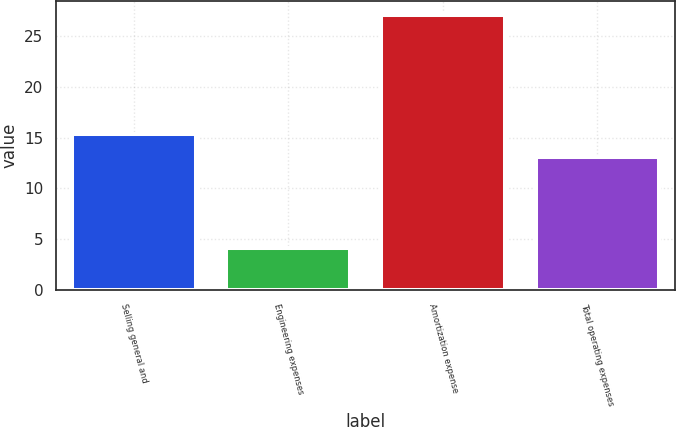Convert chart to OTSL. <chart><loc_0><loc_0><loc_500><loc_500><bar_chart><fcel>Selling general and<fcel>Engineering expenses<fcel>Amortization expense<fcel>Total operating expenses<nl><fcel>15.4<fcel>4.1<fcel>27.1<fcel>13.1<nl></chart> 